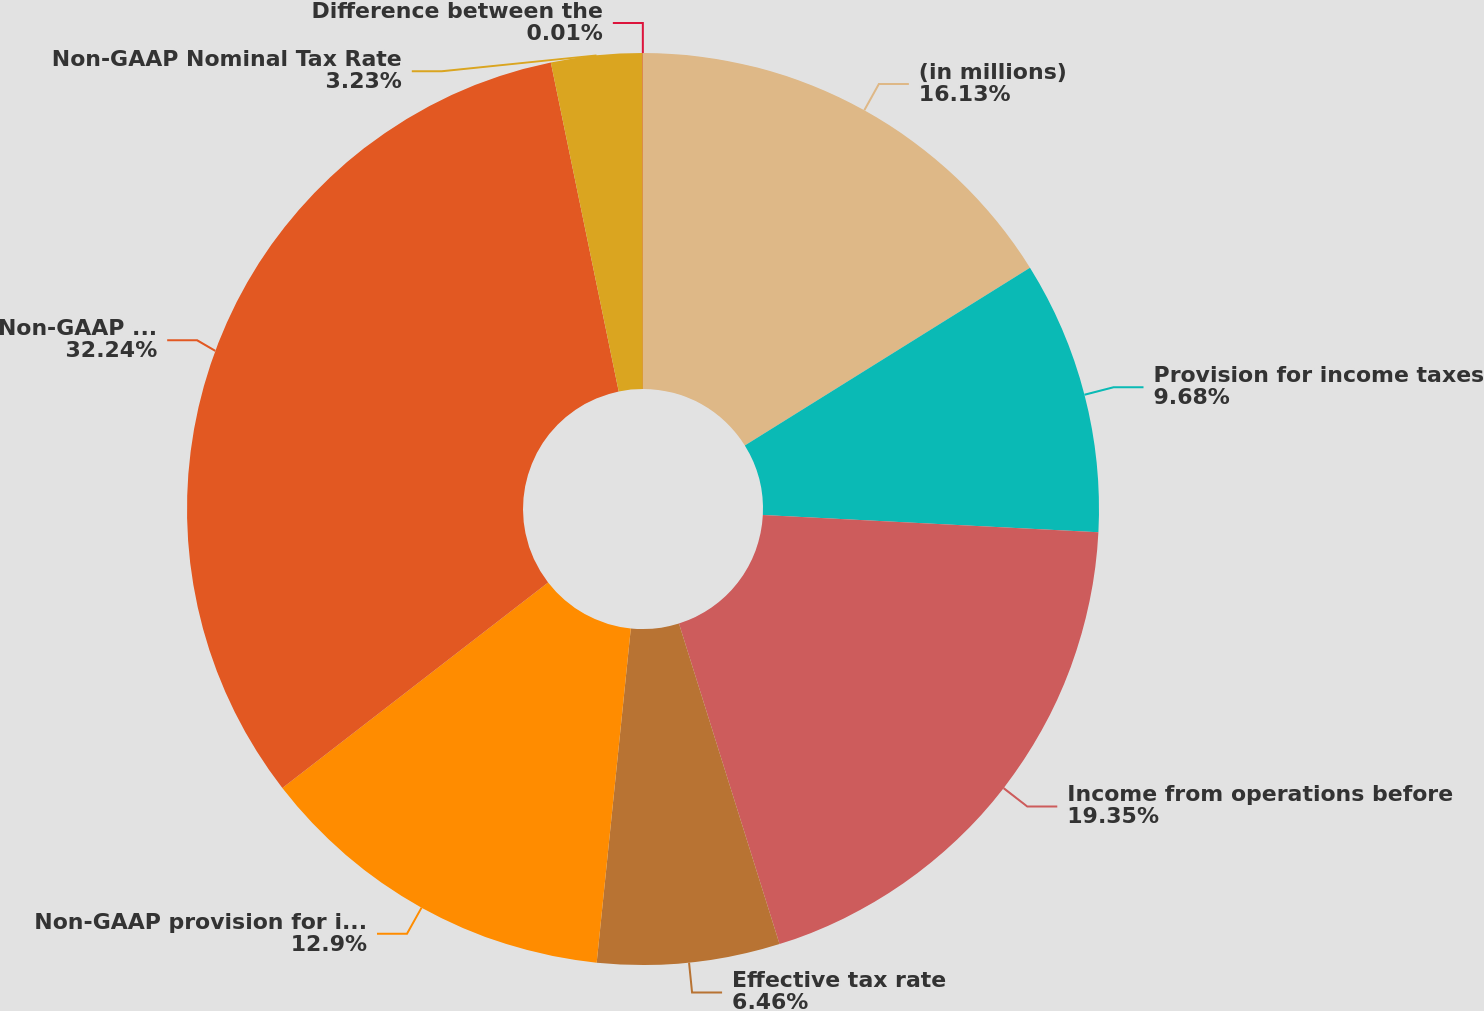Convert chart. <chart><loc_0><loc_0><loc_500><loc_500><pie_chart><fcel>(in millions)<fcel>Provision for income taxes<fcel>Income from operations before<fcel>Effective tax rate<fcel>Non-GAAP provision for income<fcel>Non-GAAP income from<fcel>Non-GAAP Nominal Tax Rate<fcel>Difference between the<nl><fcel>16.13%<fcel>9.68%<fcel>19.35%<fcel>6.46%<fcel>12.9%<fcel>32.24%<fcel>3.23%<fcel>0.01%<nl></chart> 